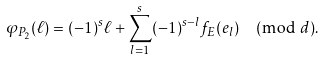<formula> <loc_0><loc_0><loc_500><loc_500>\varphi _ { P _ { 2 } } ( \ell ) = ( - 1 ) ^ { s } \ell + \sum _ { l = 1 } ^ { s } ( - 1 ) ^ { s - l } f _ { E } ( e _ { l } ) \pmod { d } .</formula> 